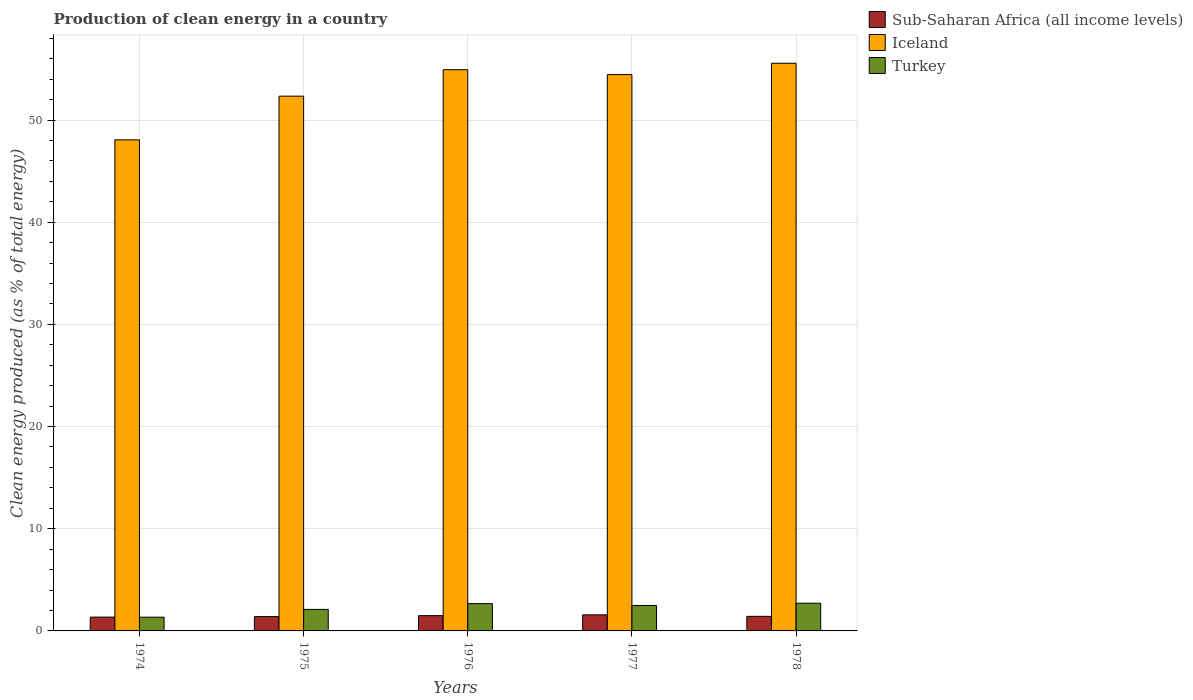Are the number of bars per tick equal to the number of legend labels?
Your response must be concise. Yes. How many bars are there on the 5th tick from the left?
Provide a short and direct response. 3. What is the label of the 4th group of bars from the left?
Your answer should be compact. 1977. In how many cases, is the number of bars for a given year not equal to the number of legend labels?
Your answer should be very brief. 0. What is the percentage of clean energy produced in Iceland in 1974?
Give a very brief answer. 48.06. Across all years, what is the maximum percentage of clean energy produced in Iceland?
Provide a succinct answer. 55.55. Across all years, what is the minimum percentage of clean energy produced in Iceland?
Keep it short and to the point. 48.06. In which year was the percentage of clean energy produced in Iceland maximum?
Ensure brevity in your answer.  1978. In which year was the percentage of clean energy produced in Turkey minimum?
Make the answer very short. 1974. What is the total percentage of clean energy produced in Sub-Saharan Africa (all income levels) in the graph?
Give a very brief answer. 7.25. What is the difference between the percentage of clean energy produced in Turkey in 1977 and that in 1978?
Give a very brief answer. -0.22. What is the difference between the percentage of clean energy produced in Turkey in 1977 and the percentage of clean energy produced in Sub-Saharan Africa (all income levels) in 1978?
Your answer should be compact. 1.06. What is the average percentage of clean energy produced in Sub-Saharan Africa (all income levels) per year?
Provide a short and direct response. 1.45. In the year 1978, what is the difference between the percentage of clean energy produced in Iceland and percentage of clean energy produced in Turkey?
Make the answer very short. 52.84. In how many years, is the percentage of clean energy produced in Turkey greater than 34 %?
Ensure brevity in your answer.  0. What is the ratio of the percentage of clean energy produced in Sub-Saharan Africa (all income levels) in 1976 to that in 1978?
Provide a succinct answer. 1.05. Is the percentage of clean energy produced in Sub-Saharan Africa (all income levels) in 1975 less than that in 1976?
Keep it short and to the point. Yes. Is the difference between the percentage of clean energy produced in Iceland in 1974 and 1975 greater than the difference between the percentage of clean energy produced in Turkey in 1974 and 1975?
Provide a short and direct response. No. What is the difference between the highest and the second highest percentage of clean energy produced in Turkey?
Your answer should be compact. 0.04. What is the difference between the highest and the lowest percentage of clean energy produced in Sub-Saharan Africa (all income levels)?
Provide a short and direct response. 0.22. What does the 1st bar from the left in 1974 represents?
Keep it short and to the point. Sub-Saharan Africa (all income levels). What does the 2nd bar from the right in 1977 represents?
Provide a short and direct response. Iceland. Are all the bars in the graph horizontal?
Keep it short and to the point. No. How many years are there in the graph?
Ensure brevity in your answer.  5. Are the values on the major ticks of Y-axis written in scientific E-notation?
Your answer should be very brief. No. How many legend labels are there?
Provide a short and direct response. 3. How are the legend labels stacked?
Keep it short and to the point. Vertical. What is the title of the graph?
Keep it short and to the point. Production of clean energy in a country. Does "Puerto Rico" appear as one of the legend labels in the graph?
Make the answer very short. No. What is the label or title of the X-axis?
Your response must be concise. Years. What is the label or title of the Y-axis?
Provide a succinct answer. Clean energy produced (as % of total energy). What is the Clean energy produced (as % of total energy) of Sub-Saharan Africa (all income levels) in 1974?
Your response must be concise. 1.35. What is the Clean energy produced (as % of total energy) of Iceland in 1974?
Your response must be concise. 48.06. What is the Clean energy produced (as % of total energy) of Turkey in 1974?
Provide a short and direct response. 1.34. What is the Clean energy produced (as % of total energy) of Sub-Saharan Africa (all income levels) in 1975?
Ensure brevity in your answer.  1.4. What is the Clean energy produced (as % of total energy) of Iceland in 1975?
Offer a terse response. 52.34. What is the Clean energy produced (as % of total energy) of Turkey in 1975?
Provide a succinct answer. 2.11. What is the Clean energy produced (as % of total energy) of Sub-Saharan Africa (all income levels) in 1976?
Provide a short and direct response. 1.49. What is the Clean energy produced (as % of total energy) of Iceland in 1976?
Ensure brevity in your answer.  54.92. What is the Clean energy produced (as % of total energy) in Turkey in 1976?
Ensure brevity in your answer.  2.67. What is the Clean energy produced (as % of total energy) of Sub-Saharan Africa (all income levels) in 1977?
Ensure brevity in your answer.  1.58. What is the Clean energy produced (as % of total energy) of Iceland in 1977?
Your answer should be compact. 54.45. What is the Clean energy produced (as % of total energy) of Turkey in 1977?
Provide a short and direct response. 2.49. What is the Clean energy produced (as % of total energy) of Sub-Saharan Africa (all income levels) in 1978?
Give a very brief answer. 1.43. What is the Clean energy produced (as % of total energy) of Iceland in 1978?
Offer a very short reply. 55.55. What is the Clean energy produced (as % of total energy) in Turkey in 1978?
Keep it short and to the point. 2.71. Across all years, what is the maximum Clean energy produced (as % of total energy) in Sub-Saharan Africa (all income levels)?
Your answer should be compact. 1.58. Across all years, what is the maximum Clean energy produced (as % of total energy) in Iceland?
Offer a very short reply. 55.55. Across all years, what is the maximum Clean energy produced (as % of total energy) of Turkey?
Keep it short and to the point. 2.71. Across all years, what is the minimum Clean energy produced (as % of total energy) in Sub-Saharan Africa (all income levels)?
Provide a succinct answer. 1.35. Across all years, what is the minimum Clean energy produced (as % of total energy) of Iceland?
Give a very brief answer. 48.06. Across all years, what is the minimum Clean energy produced (as % of total energy) in Turkey?
Make the answer very short. 1.34. What is the total Clean energy produced (as % of total energy) in Sub-Saharan Africa (all income levels) in the graph?
Ensure brevity in your answer.  7.25. What is the total Clean energy produced (as % of total energy) of Iceland in the graph?
Provide a succinct answer. 265.32. What is the total Clean energy produced (as % of total energy) in Turkey in the graph?
Ensure brevity in your answer.  11.33. What is the difference between the Clean energy produced (as % of total energy) of Sub-Saharan Africa (all income levels) in 1974 and that in 1975?
Your answer should be very brief. -0.05. What is the difference between the Clean energy produced (as % of total energy) in Iceland in 1974 and that in 1975?
Your answer should be very brief. -4.27. What is the difference between the Clean energy produced (as % of total energy) of Turkey in 1974 and that in 1975?
Offer a terse response. -0.76. What is the difference between the Clean energy produced (as % of total energy) in Sub-Saharan Africa (all income levels) in 1974 and that in 1976?
Offer a very short reply. -0.14. What is the difference between the Clean energy produced (as % of total energy) of Iceland in 1974 and that in 1976?
Your answer should be very brief. -6.86. What is the difference between the Clean energy produced (as % of total energy) in Turkey in 1974 and that in 1976?
Keep it short and to the point. -1.33. What is the difference between the Clean energy produced (as % of total energy) in Sub-Saharan Africa (all income levels) in 1974 and that in 1977?
Ensure brevity in your answer.  -0.22. What is the difference between the Clean energy produced (as % of total energy) of Iceland in 1974 and that in 1977?
Your answer should be compact. -6.39. What is the difference between the Clean energy produced (as % of total energy) in Turkey in 1974 and that in 1977?
Offer a terse response. -1.15. What is the difference between the Clean energy produced (as % of total energy) of Sub-Saharan Africa (all income levels) in 1974 and that in 1978?
Ensure brevity in your answer.  -0.07. What is the difference between the Clean energy produced (as % of total energy) in Iceland in 1974 and that in 1978?
Offer a terse response. -7.49. What is the difference between the Clean energy produced (as % of total energy) in Turkey in 1974 and that in 1978?
Provide a short and direct response. -1.37. What is the difference between the Clean energy produced (as % of total energy) of Sub-Saharan Africa (all income levels) in 1975 and that in 1976?
Give a very brief answer. -0.09. What is the difference between the Clean energy produced (as % of total energy) in Iceland in 1975 and that in 1976?
Offer a terse response. -2.59. What is the difference between the Clean energy produced (as % of total energy) in Turkey in 1975 and that in 1976?
Offer a terse response. -0.57. What is the difference between the Clean energy produced (as % of total energy) of Sub-Saharan Africa (all income levels) in 1975 and that in 1977?
Provide a short and direct response. -0.17. What is the difference between the Clean energy produced (as % of total energy) in Iceland in 1975 and that in 1977?
Your response must be concise. -2.11. What is the difference between the Clean energy produced (as % of total energy) in Turkey in 1975 and that in 1977?
Your answer should be very brief. -0.38. What is the difference between the Clean energy produced (as % of total energy) of Sub-Saharan Africa (all income levels) in 1975 and that in 1978?
Make the answer very short. -0.02. What is the difference between the Clean energy produced (as % of total energy) of Iceland in 1975 and that in 1978?
Keep it short and to the point. -3.22. What is the difference between the Clean energy produced (as % of total energy) in Turkey in 1975 and that in 1978?
Provide a succinct answer. -0.61. What is the difference between the Clean energy produced (as % of total energy) of Sub-Saharan Africa (all income levels) in 1976 and that in 1977?
Your response must be concise. -0.08. What is the difference between the Clean energy produced (as % of total energy) in Iceland in 1976 and that in 1977?
Keep it short and to the point. 0.48. What is the difference between the Clean energy produced (as % of total energy) in Turkey in 1976 and that in 1977?
Ensure brevity in your answer.  0.18. What is the difference between the Clean energy produced (as % of total energy) in Sub-Saharan Africa (all income levels) in 1976 and that in 1978?
Your answer should be compact. 0.07. What is the difference between the Clean energy produced (as % of total energy) of Iceland in 1976 and that in 1978?
Your answer should be compact. -0.63. What is the difference between the Clean energy produced (as % of total energy) of Turkey in 1976 and that in 1978?
Provide a succinct answer. -0.04. What is the difference between the Clean energy produced (as % of total energy) in Sub-Saharan Africa (all income levels) in 1977 and that in 1978?
Your answer should be compact. 0.15. What is the difference between the Clean energy produced (as % of total energy) of Iceland in 1977 and that in 1978?
Keep it short and to the point. -1.11. What is the difference between the Clean energy produced (as % of total energy) in Turkey in 1977 and that in 1978?
Your response must be concise. -0.22. What is the difference between the Clean energy produced (as % of total energy) of Sub-Saharan Africa (all income levels) in 1974 and the Clean energy produced (as % of total energy) of Iceland in 1975?
Your answer should be very brief. -50.98. What is the difference between the Clean energy produced (as % of total energy) in Sub-Saharan Africa (all income levels) in 1974 and the Clean energy produced (as % of total energy) in Turkey in 1975?
Your answer should be compact. -0.75. What is the difference between the Clean energy produced (as % of total energy) of Iceland in 1974 and the Clean energy produced (as % of total energy) of Turkey in 1975?
Offer a terse response. 45.96. What is the difference between the Clean energy produced (as % of total energy) in Sub-Saharan Africa (all income levels) in 1974 and the Clean energy produced (as % of total energy) in Iceland in 1976?
Give a very brief answer. -53.57. What is the difference between the Clean energy produced (as % of total energy) in Sub-Saharan Africa (all income levels) in 1974 and the Clean energy produced (as % of total energy) in Turkey in 1976?
Your answer should be compact. -1.32. What is the difference between the Clean energy produced (as % of total energy) of Iceland in 1974 and the Clean energy produced (as % of total energy) of Turkey in 1976?
Ensure brevity in your answer.  45.39. What is the difference between the Clean energy produced (as % of total energy) of Sub-Saharan Africa (all income levels) in 1974 and the Clean energy produced (as % of total energy) of Iceland in 1977?
Offer a terse response. -53.09. What is the difference between the Clean energy produced (as % of total energy) in Sub-Saharan Africa (all income levels) in 1974 and the Clean energy produced (as % of total energy) in Turkey in 1977?
Offer a terse response. -1.14. What is the difference between the Clean energy produced (as % of total energy) in Iceland in 1974 and the Clean energy produced (as % of total energy) in Turkey in 1977?
Your answer should be compact. 45.57. What is the difference between the Clean energy produced (as % of total energy) of Sub-Saharan Africa (all income levels) in 1974 and the Clean energy produced (as % of total energy) of Iceland in 1978?
Your answer should be compact. -54.2. What is the difference between the Clean energy produced (as % of total energy) in Sub-Saharan Africa (all income levels) in 1974 and the Clean energy produced (as % of total energy) in Turkey in 1978?
Give a very brief answer. -1.36. What is the difference between the Clean energy produced (as % of total energy) in Iceland in 1974 and the Clean energy produced (as % of total energy) in Turkey in 1978?
Your answer should be compact. 45.35. What is the difference between the Clean energy produced (as % of total energy) in Sub-Saharan Africa (all income levels) in 1975 and the Clean energy produced (as % of total energy) in Iceland in 1976?
Ensure brevity in your answer.  -53.52. What is the difference between the Clean energy produced (as % of total energy) of Sub-Saharan Africa (all income levels) in 1975 and the Clean energy produced (as % of total energy) of Turkey in 1976?
Keep it short and to the point. -1.27. What is the difference between the Clean energy produced (as % of total energy) in Iceland in 1975 and the Clean energy produced (as % of total energy) in Turkey in 1976?
Provide a succinct answer. 49.66. What is the difference between the Clean energy produced (as % of total energy) in Sub-Saharan Africa (all income levels) in 1975 and the Clean energy produced (as % of total energy) in Iceland in 1977?
Keep it short and to the point. -53.04. What is the difference between the Clean energy produced (as % of total energy) of Sub-Saharan Africa (all income levels) in 1975 and the Clean energy produced (as % of total energy) of Turkey in 1977?
Provide a succinct answer. -1.09. What is the difference between the Clean energy produced (as % of total energy) in Iceland in 1975 and the Clean energy produced (as % of total energy) in Turkey in 1977?
Give a very brief answer. 49.84. What is the difference between the Clean energy produced (as % of total energy) in Sub-Saharan Africa (all income levels) in 1975 and the Clean energy produced (as % of total energy) in Iceland in 1978?
Provide a succinct answer. -54.15. What is the difference between the Clean energy produced (as % of total energy) in Sub-Saharan Africa (all income levels) in 1975 and the Clean energy produced (as % of total energy) in Turkey in 1978?
Give a very brief answer. -1.31. What is the difference between the Clean energy produced (as % of total energy) of Iceland in 1975 and the Clean energy produced (as % of total energy) of Turkey in 1978?
Offer a very short reply. 49.62. What is the difference between the Clean energy produced (as % of total energy) in Sub-Saharan Africa (all income levels) in 1976 and the Clean energy produced (as % of total energy) in Iceland in 1977?
Keep it short and to the point. -52.95. What is the difference between the Clean energy produced (as % of total energy) of Sub-Saharan Africa (all income levels) in 1976 and the Clean energy produced (as % of total energy) of Turkey in 1977?
Your response must be concise. -1. What is the difference between the Clean energy produced (as % of total energy) of Iceland in 1976 and the Clean energy produced (as % of total energy) of Turkey in 1977?
Provide a succinct answer. 52.43. What is the difference between the Clean energy produced (as % of total energy) in Sub-Saharan Africa (all income levels) in 1976 and the Clean energy produced (as % of total energy) in Iceland in 1978?
Provide a succinct answer. -54.06. What is the difference between the Clean energy produced (as % of total energy) of Sub-Saharan Africa (all income levels) in 1976 and the Clean energy produced (as % of total energy) of Turkey in 1978?
Offer a very short reply. -1.22. What is the difference between the Clean energy produced (as % of total energy) in Iceland in 1976 and the Clean energy produced (as % of total energy) in Turkey in 1978?
Provide a short and direct response. 52.21. What is the difference between the Clean energy produced (as % of total energy) of Sub-Saharan Africa (all income levels) in 1977 and the Clean energy produced (as % of total energy) of Iceland in 1978?
Offer a terse response. -53.98. What is the difference between the Clean energy produced (as % of total energy) of Sub-Saharan Africa (all income levels) in 1977 and the Clean energy produced (as % of total energy) of Turkey in 1978?
Provide a short and direct response. -1.14. What is the difference between the Clean energy produced (as % of total energy) of Iceland in 1977 and the Clean energy produced (as % of total energy) of Turkey in 1978?
Make the answer very short. 51.73. What is the average Clean energy produced (as % of total energy) in Sub-Saharan Africa (all income levels) per year?
Make the answer very short. 1.45. What is the average Clean energy produced (as % of total energy) in Iceland per year?
Ensure brevity in your answer.  53.06. What is the average Clean energy produced (as % of total energy) in Turkey per year?
Your answer should be compact. 2.27. In the year 1974, what is the difference between the Clean energy produced (as % of total energy) in Sub-Saharan Africa (all income levels) and Clean energy produced (as % of total energy) in Iceland?
Ensure brevity in your answer.  -46.71. In the year 1974, what is the difference between the Clean energy produced (as % of total energy) of Sub-Saharan Africa (all income levels) and Clean energy produced (as % of total energy) of Turkey?
Keep it short and to the point. 0.01. In the year 1974, what is the difference between the Clean energy produced (as % of total energy) of Iceland and Clean energy produced (as % of total energy) of Turkey?
Give a very brief answer. 46.72. In the year 1975, what is the difference between the Clean energy produced (as % of total energy) in Sub-Saharan Africa (all income levels) and Clean energy produced (as % of total energy) in Iceland?
Give a very brief answer. -50.93. In the year 1975, what is the difference between the Clean energy produced (as % of total energy) in Sub-Saharan Africa (all income levels) and Clean energy produced (as % of total energy) in Turkey?
Ensure brevity in your answer.  -0.7. In the year 1975, what is the difference between the Clean energy produced (as % of total energy) in Iceland and Clean energy produced (as % of total energy) in Turkey?
Offer a terse response. 50.23. In the year 1976, what is the difference between the Clean energy produced (as % of total energy) in Sub-Saharan Africa (all income levels) and Clean energy produced (as % of total energy) in Iceland?
Keep it short and to the point. -53.43. In the year 1976, what is the difference between the Clean energy produced (as % of total energy) in Sub-Saharan Africa (all income levels) and Clean energy produced (as % of total energy) in Turkey?
Your answer should be very brief. -1.18. In the year 1976, what is the difference between the Clean energy produced (as % of total energy) in Iceland and Clean energy produced (as % of total energy) in Turkey?
Give a very brief answer. 52.25. In the year 1977, what is the difference between the Clean energy produced (as % of total energy) in Sub-Saharan Africa (all income levels) and Clean energy produced (as % of total energy) in Iceland?
Offer a very short reply. -52.87. In the year 1977, what is the difference between the Clean energy produced (as % of total energy) in Sub-Saharan Africa (all income levels) and Clean energy produced (as % of total energy) in Turkey?
Offer a very short reply. -0.91. In the year 1977, what is the difference between the Clean energy produced (as % of total energy) of Iceland and Clean energy produced (as % of total energy) of Turkey?
Offer a terse response. 51.96. In the year 1978, what is the difference between the Clean energy produced (as % of total energy) of Sub-Saharan Africa (all income levels) and Clean energy produced (as % of total energy) of Iceland?
Offer a terse response. -54.13. In the year 1978, what is the difference between the Clean energy produced (as % of total energy) of Sub-Saharan Africa (all income levels) and Clean energy produced (as % of total energy) of Turkey?
Your response must be concise. -1.29. In the year 1978, what is the difference between the Clean energy produced (as % of total energy) of Iceland and Clean energy produced (as % of total energy) of Turkey?
Provide a succinct answer. 52.84. What is the ratio of the Clean energy produced (as % of total energy) of Iceland in 1974 to that in 1975?
Your answer should be very brief. 0.92. What is the ratio of the Clean energy produced (as % of total energy) in Turkey in 1974 to that in 1975?
Make the answer very short. 0.64. What is the ratio of the Clean energy produced (as % of total energy) in Sub-Saharan Africa (all income levels) in 1974 to that in 1976?
Your answer should be compact. 0.91. What is the ratio of the Clean energy produced (as % of total energy) of Turkey in 1974 to that in 1976?
Your answer should be compact. 0.5. What is the ratio of the Clean energy produced (as % of total energy) in Sub-Saharan Africa (all income levels) in 1974 to that in 1977?
Make the answer very short. 0.86. What is the ratio of the Clean energy produced (as % of total energy) in Iceland in 1974 to that in 1977?
Give a very brief answer. 0.88. What is the ratio of the Clean energy produced (as % of total energy) in Turkey in 1974 to that in 1977?
Your answer should be very brief. 0.54. What is the ratio of the Clean energy produced (as % of total energy) of Sub-Saharan Africa (all income levels) in 1974 to that in 1978?
Make the answer very short. 0.95. What is the ratio of the Clean energy produced (as % of total energy) in Iceland in 1974 to that in 1978?
Ensure brevity in your answer.  0.87. What is the ratio of the Clean energy produced (as % of total energy) of Turkey in 1974 to that in 1978?
Ensure brevity in your answer.  0.5. What is the ratio of the Clean energy produced (as % of total energy) of Sub-Saharan Africa (all income levels) in 1975 to that in 1976?
Offer a very short reply. 0.94. What is the ratio of the Clean energy produced (as % of total energy) of Iceland in 1975 to that in 1976?
Make the answer very short. 0.95. What is the ratio of the Clean energy produced (as % of total energy) of Turkey in 1975 to that in 1976?
Keep it short and to the point. 0.79. What is the ratio of the Clean energy produced (as % of total energy) in Sub-Saharan Africa (all income levels) in 1975 to that in 1977?
Your answer should be compact. 0.89. What is the ratio of the Clean energy produced (as % of total energy) of Iceland in 1975 to that in 1977?
Provide a short and direct response. 0.96. What is the ratio of the Clean energy produced (as % of total energy) of Turkey in 1975 to that in 1977?
Your answer should be very brief. 0.85. What is the ratio of the Clean energy produced (as % of total energy) of Iceland in 1975 to that in 1978?
Your answer should be compact. 0.94. What is the ratio of the Clean energy produced (as % of total energy) of Turkey in 1975 to that in 1978?
Offer a very short reply. 0.78. What is the ratio of the Clean energy produced (as % of total energy) in Sub-Saharan Africa (all income levels) in 1976 to that in 1977?
Your response must be concise. 0.95. What is the ratio of the Clean energy produced (as % of total energy) of Iceland in 1976 to that in 1977?
Offer a very short reply. 1.01. What is the ratio of the Clean energy produced (as % of total energy) in Turkey in 1976 to that in 1977?
Your response must be concise. 1.07. What is the ratio of the Clean energy produced (as % of total energy) in Sub-Saharan Africa (all income levels) in 1976 to that in 1978?
Your answer should be very brief. 1.05. What is the ratio of the Clean energy produced (as % of total energy) of Iceland in 1976 to that in 1978?
Keep it short and to the point. 0.99. What is the ratio of the Clean energy produced (as % of total energy) in Turkey in 1976 to that in 1978?
Provide a short and direct response. 0.98. What is the ratio of the Clean energy produced (as % of total energy) in Sub-Saharan Africa (all income levels) in 1977 to that in 1978?
Your response must be concise. 1.11. What is the ratio of the Clean energy produced (as % of total energy) of Iceland in 1977 to that in 1978?
Your response must be concise. 0.98. What is the ratio of the Clean energy produced (as % of total energy) in Turkey in 1977 to that in 1978?
Offer a very short reply. 0.92. What is the difference between the highest and the second highest Clean energy produced (as % of total energy) of Sub-Saharan Africa (all income levels)?
Give a very brief answer. 0.08. What is the difference between the highest and the second highest Clean energy produced (as % of total energy) of Iceland?
Offer a very short reply. 0.63. What is the difference between the highest and the second highest Clean energy produced (as % of total energy) in Turkey?
Offer a terse response. 0.04. What is the difference between the highest and the lowest Clean energy produced (as % of total energy) in Sub-Saharan Africa (all income levels)?
Provide a short and direct response. 0.22. What is the difference between the highest and the lowest Clean energy produced (as % of total energy) of Iceland?
Your answer should be very brief. 7.49. What is the difference between the highest and the lowest Clean energy produced (as % of total energy) of Turkey?
Offer a very short reply. 1.37. 